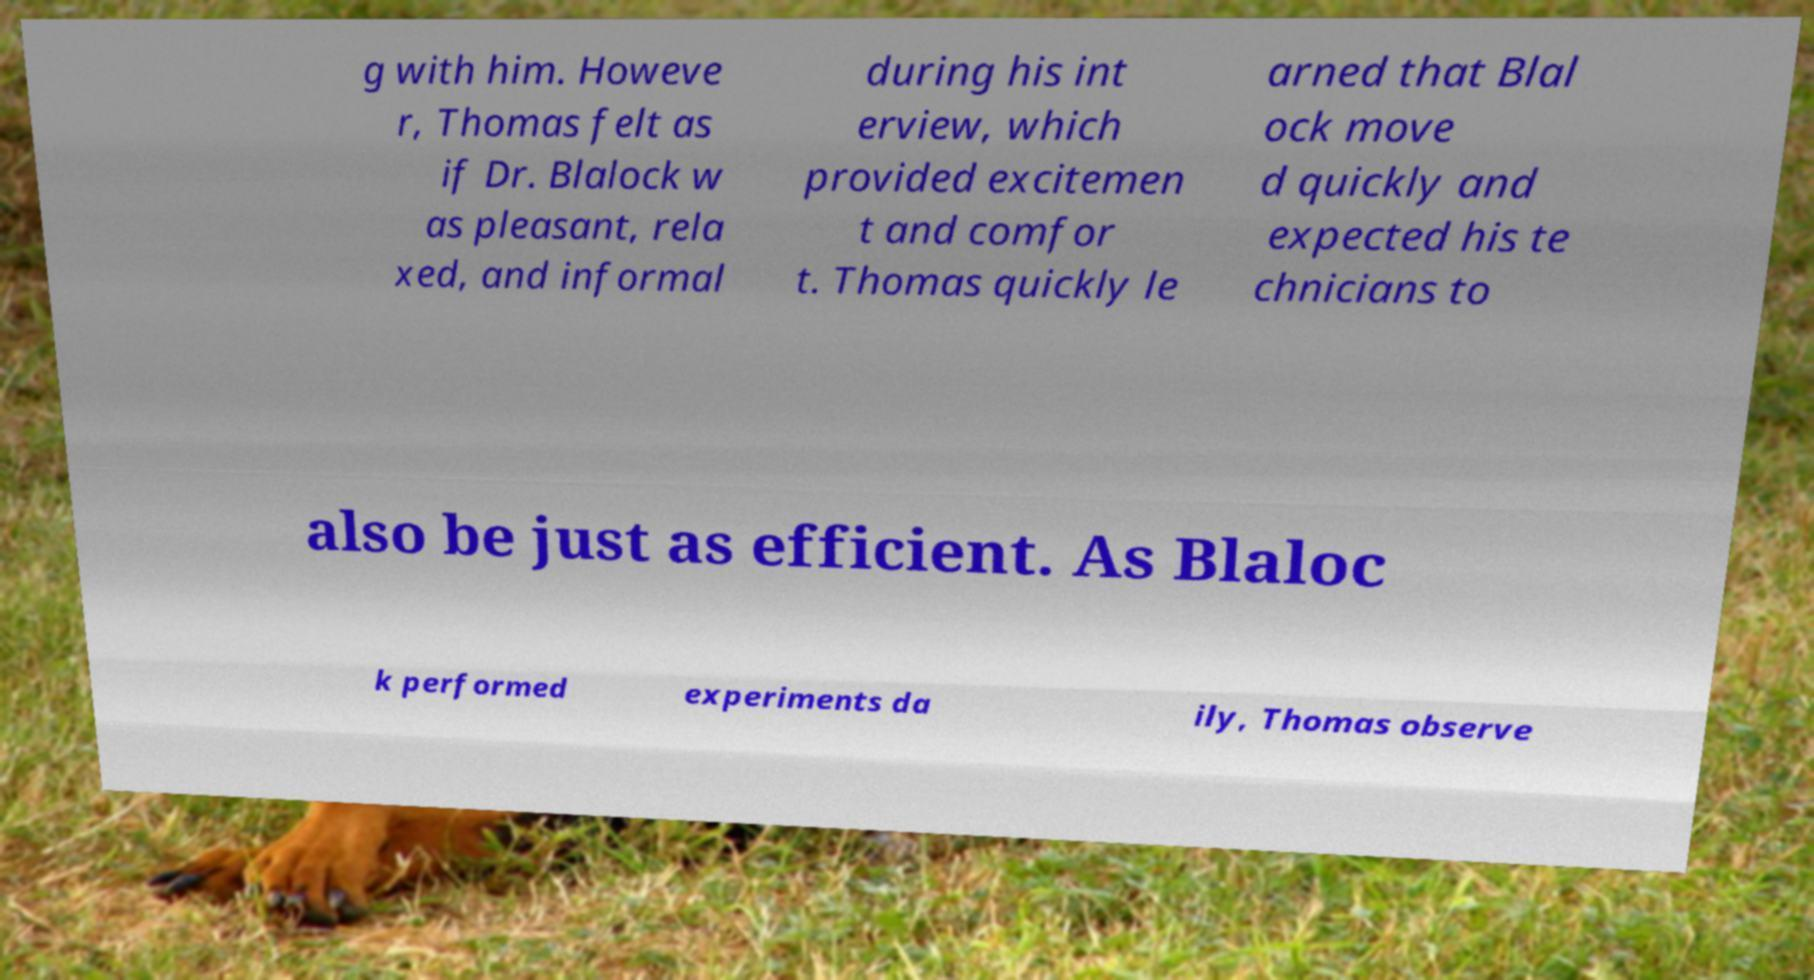Can you read and provide the text displayed in the image?This photo seems to have some interesting text. Can you extract and type it out for me? g with him. Howeve r, Thomas felt as if Dr. Blalock w as pleasant, rela xed, and informal during his int erview, which provided excitemen t and comfor t. Thomas quickly le arned that Blal ock move d quickly and expected his te chnicians to also be just as efficient. As Blaloc k performed experiments da ily, Thomas observe 